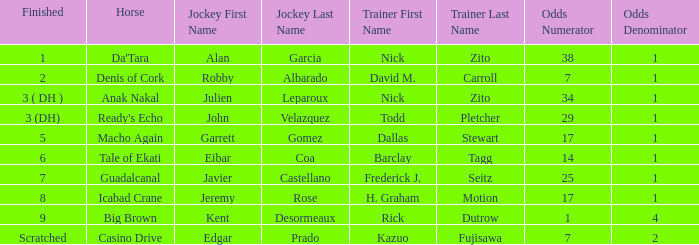What is the likelihood for the horse named ready's echo? 29-1. 